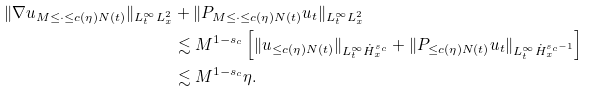Convert formula to latex. <formula><loc_0><loc_0><loc_500><loc_500>\| \nabla u _ { M \leq \cdot \leq c ( \eta ) N ( t ) } \| _ { L _ { t } ^ { \infty } L _ { x } ^ { 2 } } & + \| P _ { M \leq \cdot \leq c ( \eta ) N ( t ) } u _ { t } \| _ { L _ { t } ^ { \infty } L _ { x } ^ { 2 } } \\ & \lesssim M ^ { 1 - s _ { c } } \left [ \| u _ { \leq c ( \eta ) N ( t ) } \| _ { L _ { t } ^ { \infty } \dot { H } ^ { s _ { c } } _ { x } } + \| P _ { \leq c ( \eta ) N ( t ) } u _ { t } \| _ { L _ { t } ^ { \infty } \dot { H } ^ { s _ { c } - 1 } _ { x } } \right ] \\ & \lesssim M ^ { 1 - s _ { c } } \eta .</formula> 